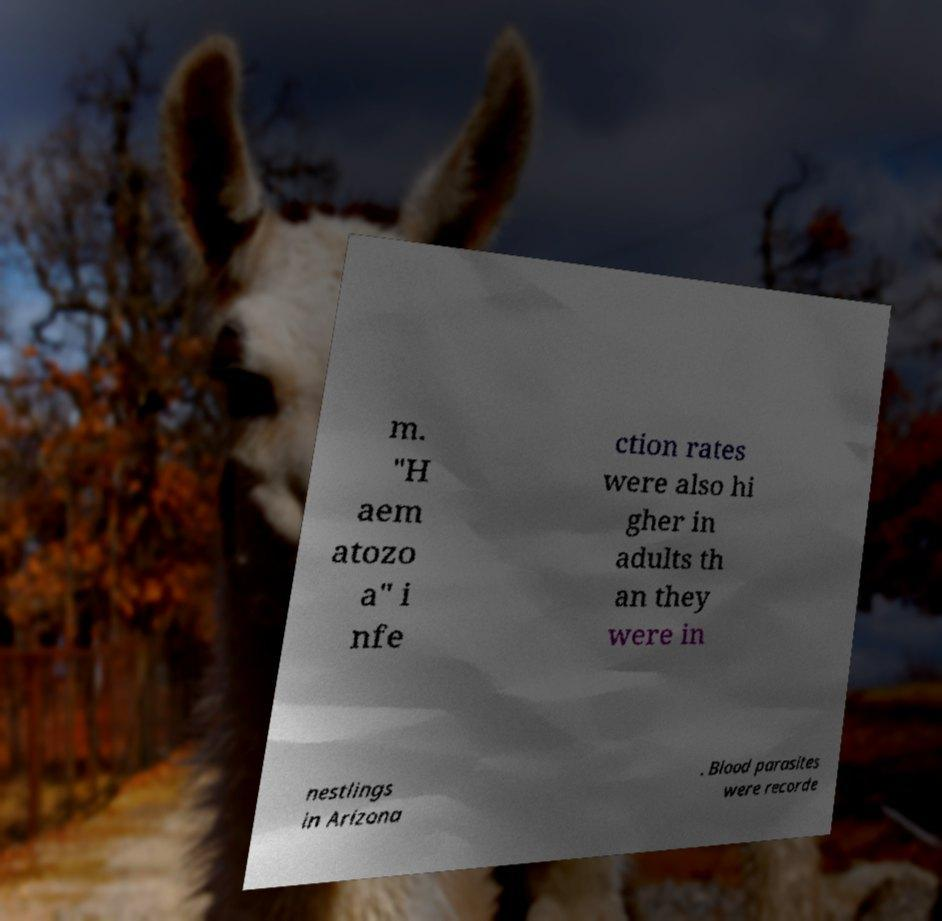There's text embedded in this image that I need extracted. Can you transcribe it verbatim? m. "H aem atozo a" i nfe ction rates were also hi gher in adults th an they were in nestlings in Arizona . Blood parasites were recorde 